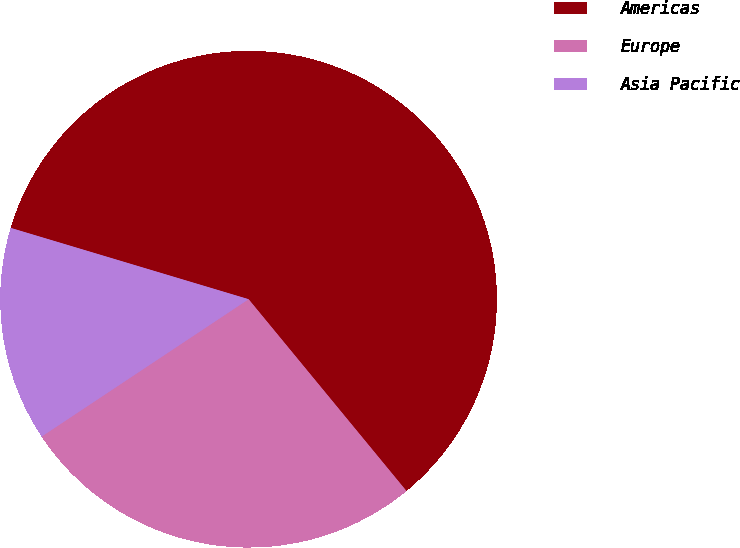Convert chart. <chart><loc_0><loc_0><loc_500><loc_500><pie_chart><fcel>Americas<fcel>Europe<fcel>Asia Pacific<nl><fcel>59.41%<fcel>26.64%<fcel>13.96%<nl></chart> 